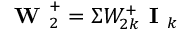Convert formula to latex. <formula><loc_0><loc_0><loc_500><loc_500>W _ { 2 } ^ { + } = \Sigma W _ { 2 k } ^ { + } I _ { k }</formula> 